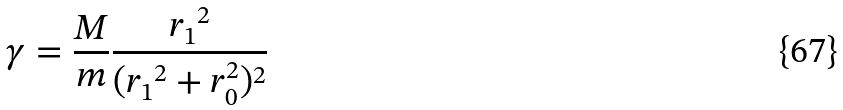Convert formula to latex. <formula><loc_0><loc_0><loc_500><loc_500>\gamma = \frac { M } { m } \frac { { r _ { 1 } } ^ { 2 } } { ( { r _ { 1 } } ^ { 2 } + r _ { 0 } ^ { 2 } ) ^ { 2 } }</formula> 